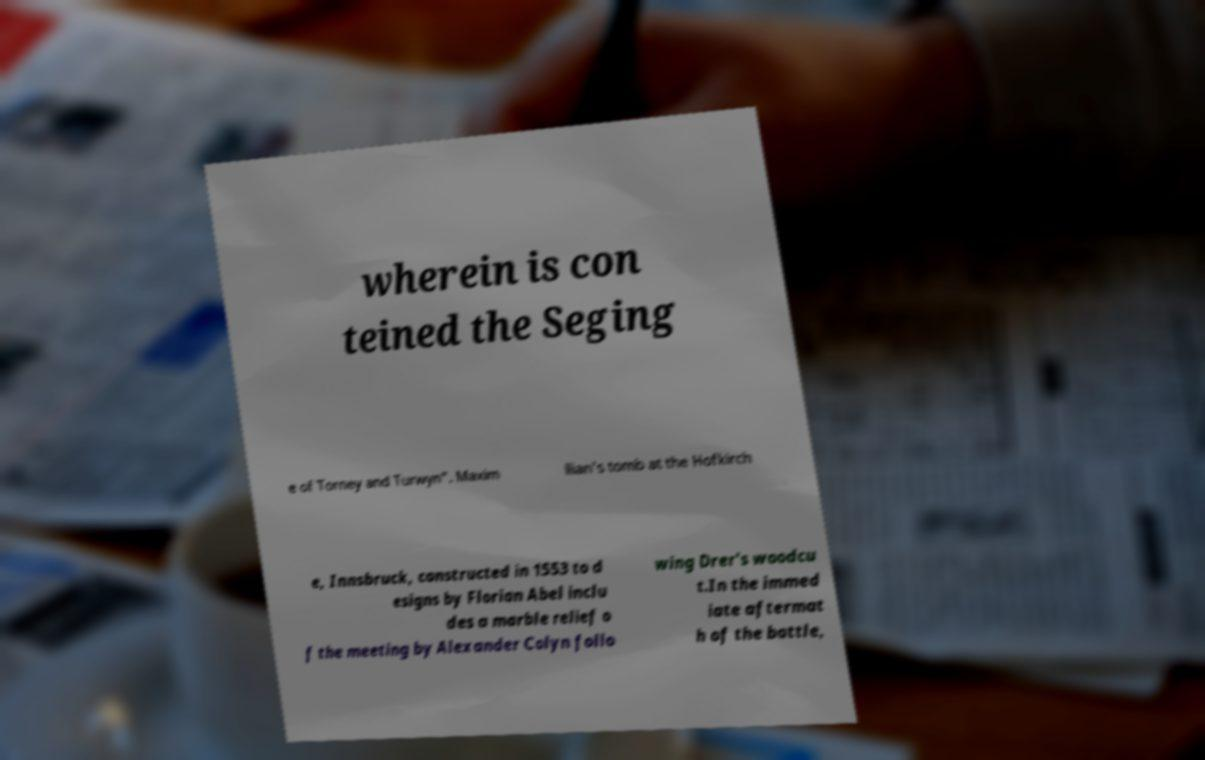Can you accurately transcribe the text from the provided image for me? wherein is con teined the Seging e of Torney and Turwyn". Maxim ilian's tomb at the Hofkirch e, Innsbruck, constructed in 1553 to d esigns by Florian Abel inclu des a marble relief o f the meeting by Alexander Colyn follo wing Drer's woodcu t.In the immed iate aftermat h of the battle, 